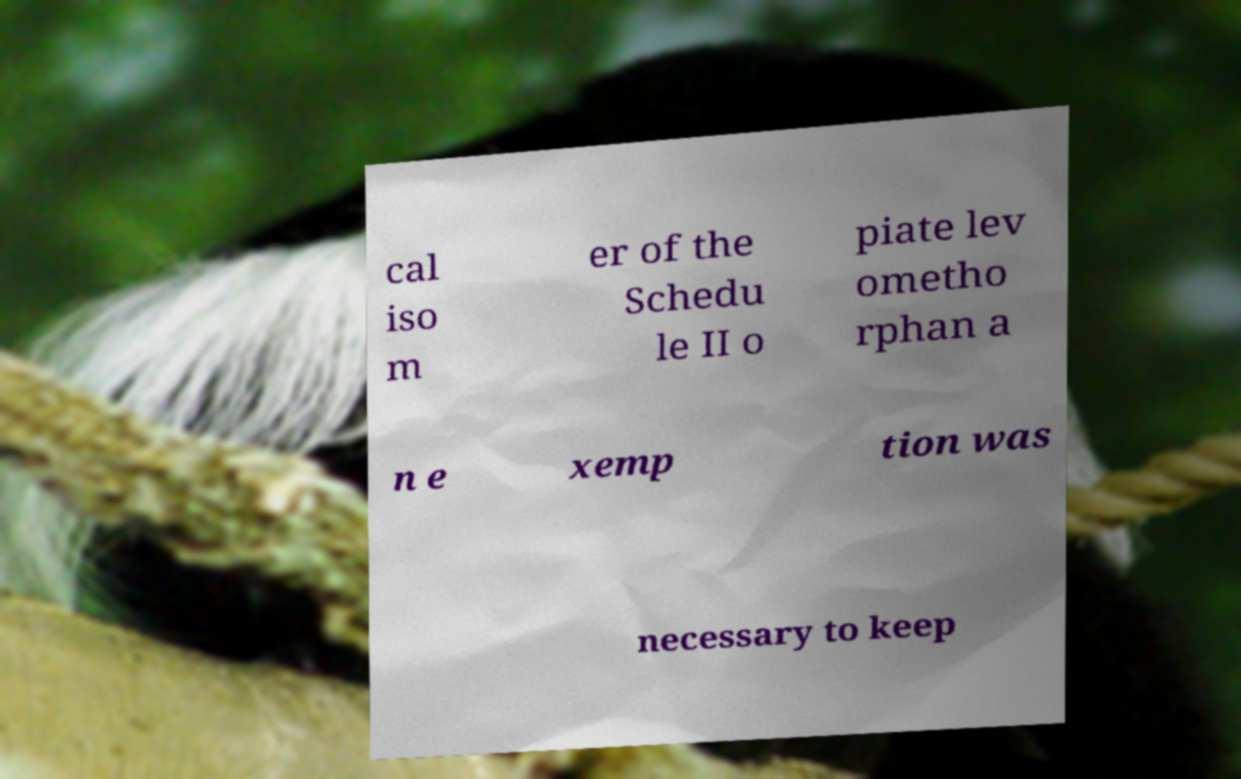What messages or text are displayed in this image? I need them in a readable, typed format. cal iso m er of the Schedu le II o piate lev ometho rphan a n e xemp tion was necessary to keep 